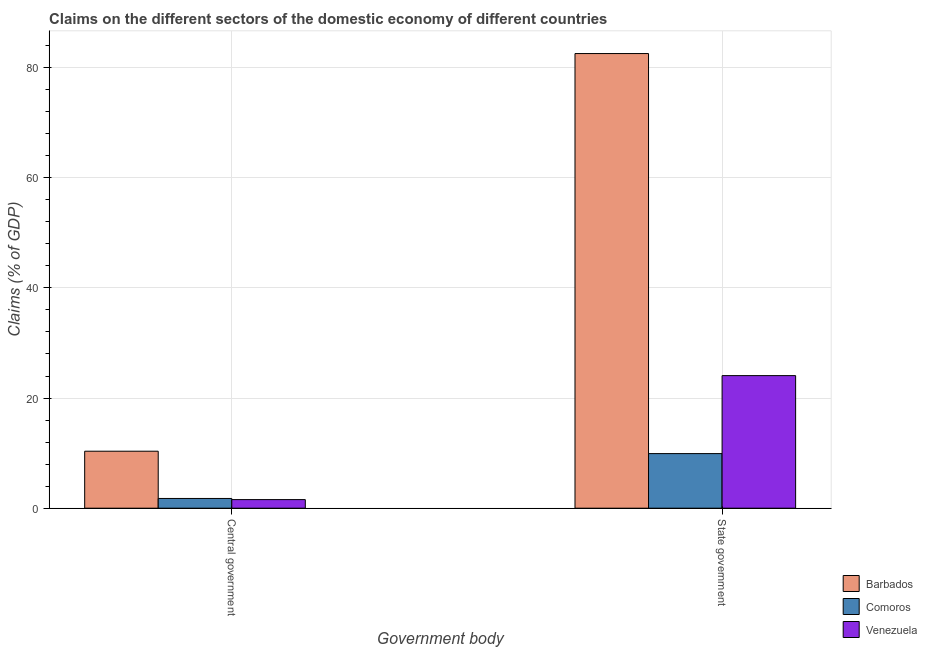How many groups of bars are there?
Provide a short and direct response. 2. Are the number of bars on each tick of the X-axis equal?
Make the answer very short. Yes. What is the label of the 1st group of bars from the left?
Provide a short and direct response. Central government. What is the claims on central government in Venezuela?
Your answer should be compact. 1.56. Across all countries, what is the maximum claims on central government?
Keep it short and to the point. 10.35. Across all countries, what is the minimum claims on central government?
Offer a very short reply. 1.56. In which country was the claims on state government maximum?
Make the answer very short. Barbados. In which country was the claims on state government minimum?
Provide a short and direct response. Comoros. What is the total claims on central government in the graph?
Your answer should be compact. 13.67. What is the difference between the claims on state government in Comoros and that in Venezuela?
Your answer should be compact. -14.16. What is the difference between the claims on state government in Barbados and the claims on central government in Comoros?
Ensure brevity in your answer.  80.77. What is the average claims on central government per country?
Give a very brief answer. 4.56. What is the difference between the claims on state government and claims on central government in Comoros?
Your answer should be compact. 8.14. What is the ratio of the claims on state government in Comoros to that in Barbados?
Keep it short and to the point. 0.12. Is the claims on central government in Comoros less than that in Barbados?
Give a very brief answer. Yes. What does the 2nd bar from the left in Central government represents?
Provide a short and direct response. Comoros. What does the 1st bar from the right in Central government represents?
Your answer should be very brief. Venezuela. How many countries are there in the graph?
Ensure brevity in your answer.  3. Are the values on the major ticks of Y-axis written in scientific E-notation?
Give a very brief answer. No. Does the graph contain any zero values?
Provide a short and direct response. No. Does the graph contain grids?
Offer a very short reply. Yes. Where does the legend appear in the graph?
Your response must be concise. Bottom right. How many legend labels are there?
Your answer should be very brief. 3. What is the title of the graph?
Provide a short and direct response. Claims on the different sectors of the domestic economy of different countries. Does "Kuwait" appear as one of the legend labels in the graph?
Keep it short and to the point. No. What is the label or title of the X-axis?
Your response must be concise. Government body. What is the label or title of the Y-axis?
Your answer should be compact. Claims (% of GDP). What is the Claims (% of GDP) in Barbados in Central government?
Provide a succinct answer. 10.35. What is the Claims (% of GDP) of Comoros in Central government?
Offer a very short reply. 1.77. What is the Claims (% of GDP) of Venezuela in Central government?
Ensure brevity in your answer.  1.56. What is the Claims (% of GDP) of Barbados in State government?
Give a very brief answer. 82.54. What is the Claims (% of GDP) of Comoros in State government?
Your response must be concise. 9.91. What is the Claims (% of GDP) of Venezuela in State government?
Provide a succinct answer. 24.07. Across all Government body, what is the maximum Claims (% of GDP) of Barbados?
Ensure brevity in your answer.  82.54. Across all Government body, what is the maximum Claims (% of GDP) in Comoros?
Your answer should be very brief. 9.91. Across all Government body, what is the maximum Claims (% of GDP) in Venezuela?
Keep it short and to the point. 24.07. Across all Government body, what is the minimum Claims (% of GDP) in Barbados?
Provide a short and direct response. 10.35. Across all Government body, what is the minimum Claims (% of GDP) in Comoros?
Give a very brief answer. 1.77. Across all Government body, what is the minimum Claims (% of GDP) of Venezuela?
Keep it short and to the point. 1.56. What is the total Claims (% of GDP) in Barbados in the graph?
Provide a short and direct response. 92.89. What is the total Claims (% of GDP) in Comoros in the graph?
Your answer should be very brief. 11.68. What is the total Claims (% of GDP) of Venezuela in the graph?
Give a very brief answer. 25.63. What is the difference between the Claims (% of GDP) in Barbados in Central government and that in State government?
Your answer should be compact. -72.2. What is the difference between the Claims (% of GDP) in Comoros in Central government and that in State government?
Offer a terse response. -8.14. What is the difference between the Claims (% of GDP) in Venezuela in Central government and that in State government?
Give a very brief answer. -22.51. What is the difference between the Claims (% of GDP) in Barbados in Central government and the Claims (% of GDP) in Comoros in State government?
Offer a terse response. 0.43. What is the difference between the Claims (% of GDP) in Barbados in Central government and the Claims (% of GDP) in Venezuela in State government?
Your answer should be compact. -13.72. What is the difference between the Claims (% of GDP) in Comoros in Central government and the Claims (% of GDP) in Venezuela in State government?
Your answer should be compact. -22.3. What is the average Claims (% of GDP) in Barbados per Government body?
Ensure brevity in your answer.  46.44. What is the average Claims (% of GDP) of Comoros per Government body?
Offer a very short reply. 5.84. What is the average Claims (% of GDP) in Venezuela per Government body?
Your answer should be compact. 12.81. What is the difference between the Claims (% of GDP) in Barbados and Claims (% of GDP) in Comoros in Central government?
Your answer should be very brief. 8.58. What is the difference between the Claims (% of GDP) in Barbados and Claims (% of GDP) in Venezuela in Central government?
Your answer should be compact. 8.79. What is the difference between the Claims (% of GDP) of Comoros and Claims (% of GDP) of Venezuela in Central government?
Your answer should be very brief. 0.21. What is the difference between the Claims (% of GDP) in Barbados and Claims (% of GDP) in Comoros in State government?
Give a very brief answer. 72.63. What is the difference between the Claims (% of GDP) of Barbados and Claims (% of GDP) of Venezuela in State government?
Give a very brief answer. 58.47. What is the difference between the Claims (% of GDP) in Comoros and Claims (% of GDP) in Venezuela in State government?
Provide a succinct answer. -14.16. What is the ratio of the Claims (% of GDP) of Barbados in Central government to that in State government?
Provide a short and direct response. 0.13. What is the ratio of the Claims (% of GDP) in Comoros in Central government to that in State government?
Your answer should be compact. 0.18. What is the ratio of the Claims (% of GDP) of Venezuela in Central government to that in State government?
Provide a succinct answer. 0.06. What is the difference between the highest and the second highest Claims (% of GDP) of Barbados?
Provide a succinct answer. 72.2. What is the difference between the highest and the second highest Claims (% of GDP) of Comoros?
Provide a short and direct response. 8.14. What is the difference between the highest and the second highest Claims (% of GDP) of Venezuela?
Give a very brief answer. 22.51. What is the difference between the highest and the lowest Claims (% of GDP) in Barbados?
Offer a very short reply. 72.2. What is the difference between the highest and the lowest Claims (% of GDP) of Comoros?
Keep it short and to the point. 8.14. What is the difference between the highest and the lowest Claims (% of GDP) of Venezuela?
Your answer should be compact. 22.51. 